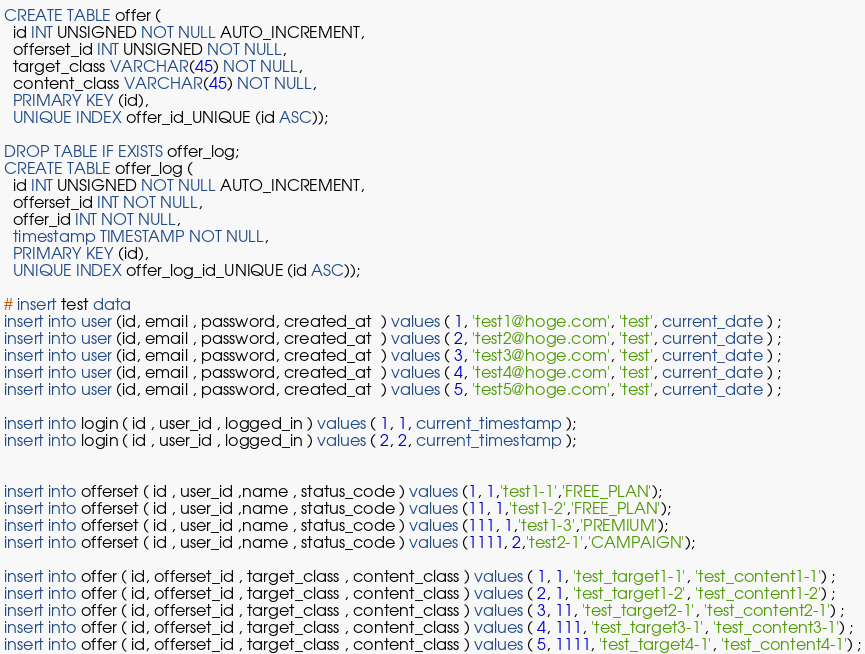<code> <loc_0><loc_0><loc_500><loc_500><_SQL_>CREATE TABLE offer (
  id INT UNSIGNED NOT NULL AUTO_INCREMENT,
  offerset_id INT UNSIGNED NOT NULL,
  target_class VARCHAR(45) NOT NULL,
  content_class VARCHAR(45) NOT NULL,
  PRIMARY KEY (id),
  UNIQUE INDEX offer_id_UNIQUE (id ASC));

DROP TABLE IF EXISTS offer_log;
CREATE TABLE offer_log (
  id INT UNSIGNED NOT NULL AUTO_INCREMENT,
  offerset_id INT NOT NULL,
  offer_id INT NOT NULL,
  timestamp TIMESTAMP NOT NULL,
  PRIMARY KEY (id),
  UNIQUE INDEX offer_log_id_UNIQUE (id ASC));

# insert test data
insert into user (id, email , password, created_at  ) values ( 1, 'test1@hoge.com', 'test', current_date ) ;
insert into user (id, email , password, created_at  ) values ( 2, 'test2@hoge.com', 'test', current_date ) ;
insert into user (id, email , password, created_at  ) values ( 3, 'test3@hoge.com', 'test', current_date ) ;
insert into user (id, email , password, created_at  ) values ( 4, 'test4@hoge.com', 'test', current_date ) ;
insert into user (id, email , password, created_at  ) values ( 5, 'test5@hoge.com', 'test', current_date ) ;

insert into login ( id , user_id , logged_in ) values ( 1, 1, current_timestamp );
insert into login ( id , user_id , logged_in ) values ( 2, 2, current_timestamp );


insert into offerset ( id , user_id ,name , status_code ) values (1, 1,'test1-1','FREE_PLAN');
insert into offerset ( id , user_id ,name , status_code ) values (11, 1,'test1-2','FREE_PLAN');
insert into offerset ( id , user_id ,name , status_code ) values (111, 1,'test1-3','PREMIUM');
insert into offerset ( id , user_id ,name , status_code ) values (1111, 2,'test2-1','CAMPAIGN');

insert into offer ( id, offerset_id , target_class , content_class ) values ( 1, 1, 'test_target1-1', 'test_content1-1') ;
insert into offer ( id, offerset_id , target_class , content_class ) values ( 2, 1, 'test_target1-2', 'test_content1-2') ;
insert into offer ( id, offerset_id , target_class , content_class ) values ( 3, 11, 'test_target2-1', 'test_content2-1') ;
insert into offer ( id, offerset_id , target_class , content_class ) values ( 4, 111, 'test_target3-1', 'test_content3-1') ;
insert into offer ( id, offerset_id , target_class , content_class ) values ( 5, 1111, 'test_target4-1', 'test_content4-1') ;
</code> 